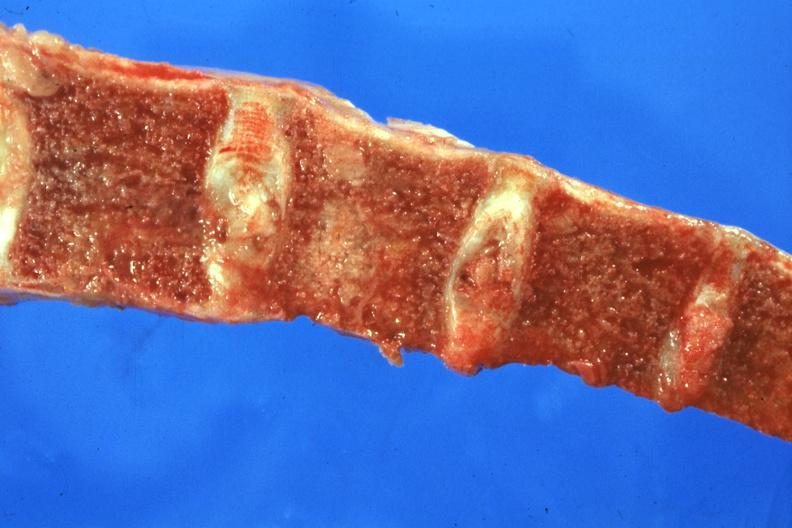what does this image show?
Answer the question using a single word or phrase. Sectioned bone with two nodules of tumor 